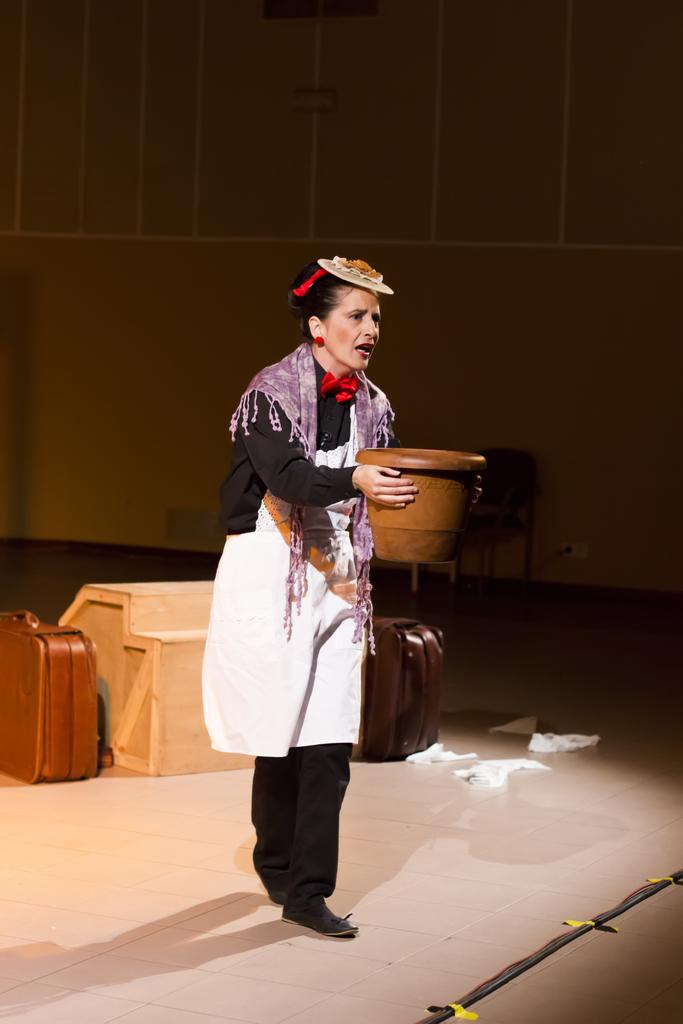What is the main subject of the image? There is a girl standing in the image. What is the girl holding in the image? The girl is holding an object. Can you describe the background of the image? There are different objects visible in the background of the image. What type of ghost can be seen interacting with the girl in the image? There is no ghost present in the image; it only features a girl holding an object and different objects in the background. Can you tell me how many toads are visible in the image? There are no toads visible in the image. 